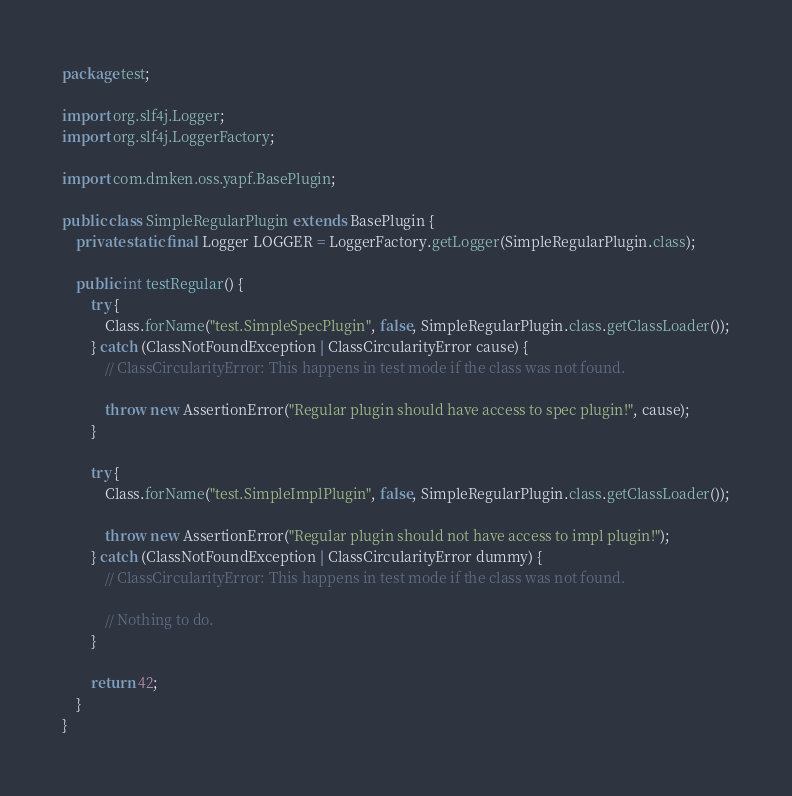Convert code to text. <code><loc_0><loc_0><loc_500><loc_500><_Java_>package test;

import org.slf4j.Logger;
import org.slf4j.LoggerFactory;

import com.dmken.oss.yapf.BasePlugin;

public class SimpleRegularPlugin extends BasePlugin {
    private static final Logger LOGGER = LoggerFactory.getLogger(SimpleRegularPlugin.class);

    public int testRegular() {
        try {
            Class.forName("test.SimpleSpecPlugin", false, SimpleRegularPlugin.class.getClassLoader());
        } catch (ClassNotFoundException | ClassCircularityError cause) {
            // ClassCircularityError: This happens in test mode if the class was not found.

            throw new AssertionError("Regular plugin should have access to spec plugin!", cause);
        }

        try {
            Class.forName("test.SimpleImplPlugin", false, SimpleRegularPlugin.class.getClassLoader());

            throw new AssertionError("Regular plugin should not have access to impl plugin!");
        } catch (ClassNotFoundException | ClassCircularityError dummy) {
            // ClassCircularityError: This happens in test mode if the class was not found.

            // Nothing to do.
        }

        return 42;
    }
}
</code> 